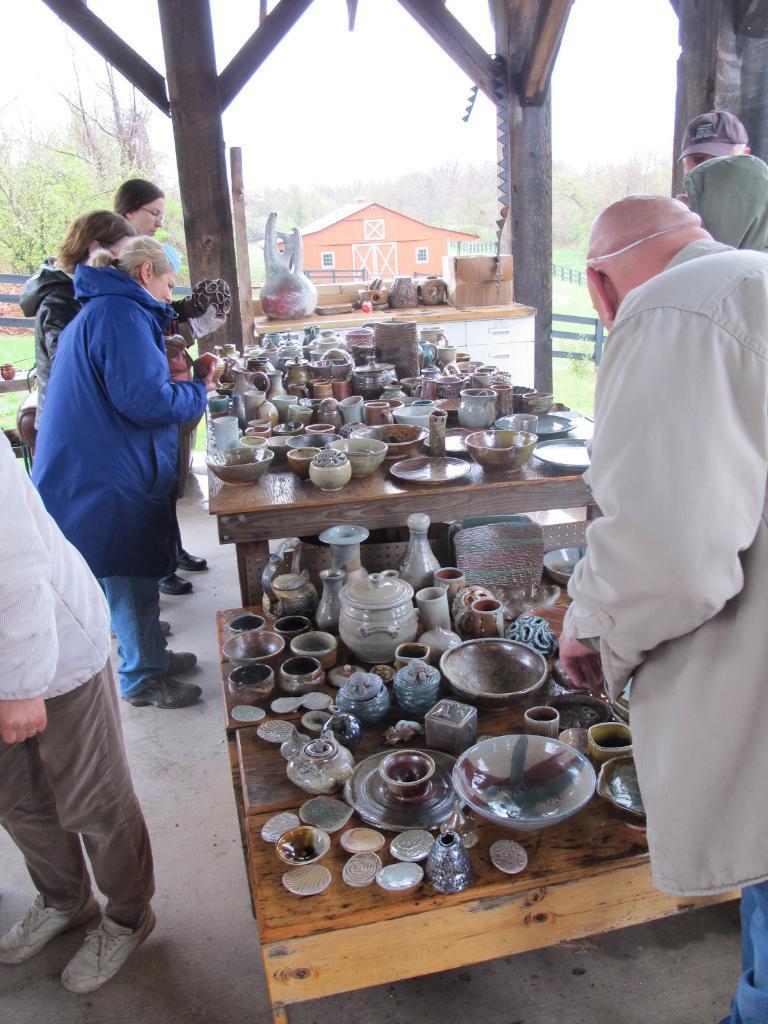Describe this image in one or two sentences. In this picture there are people, tables, different bowls, jars and other objects. In the center of the picture there are pillars, bowls, trees, fencing and grass. In the background there are trees and house. At the top it is sky. 